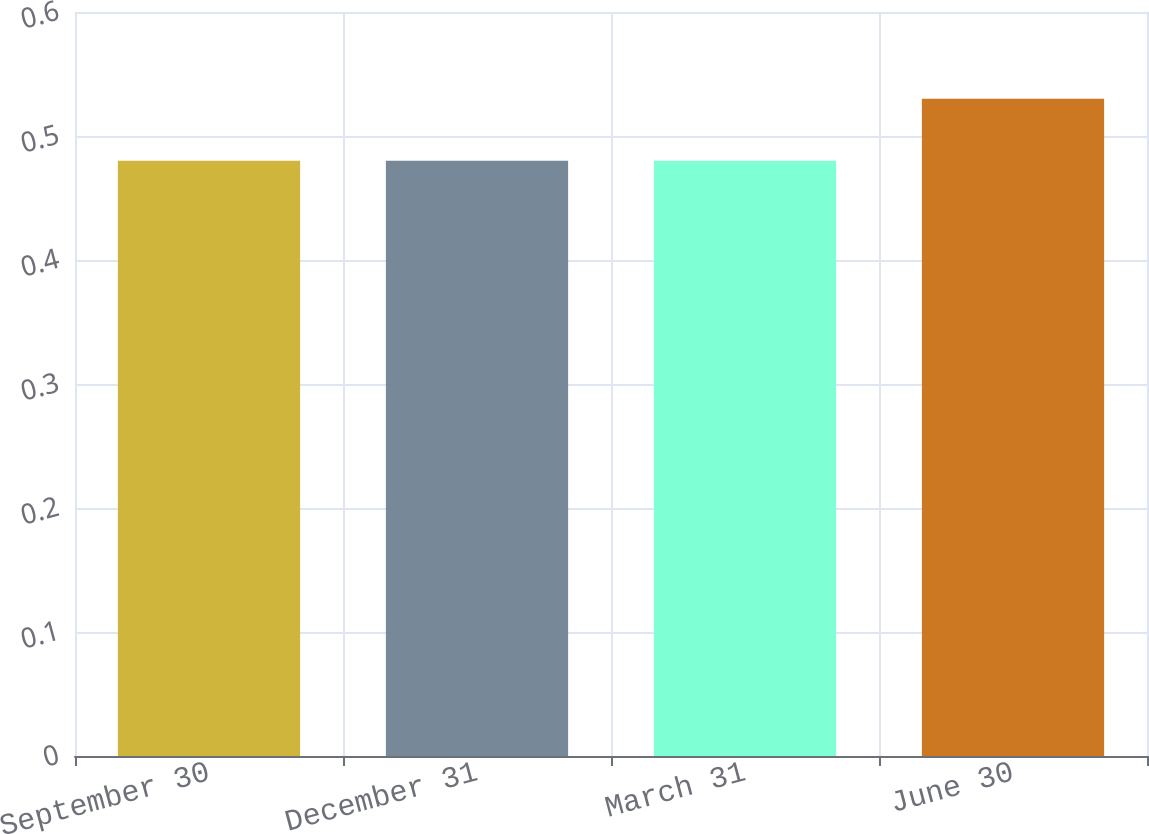Convert chart. <chart><loc_0><loc_0><loc_500><loc_500><bar_chart><fcel>September 30<fcel>December 31<fcel>March 31<fcel>June 30<nl><fcel>0.48<fcel>0.48<fcel>0.48<fcel>0.53<nl></chart> 